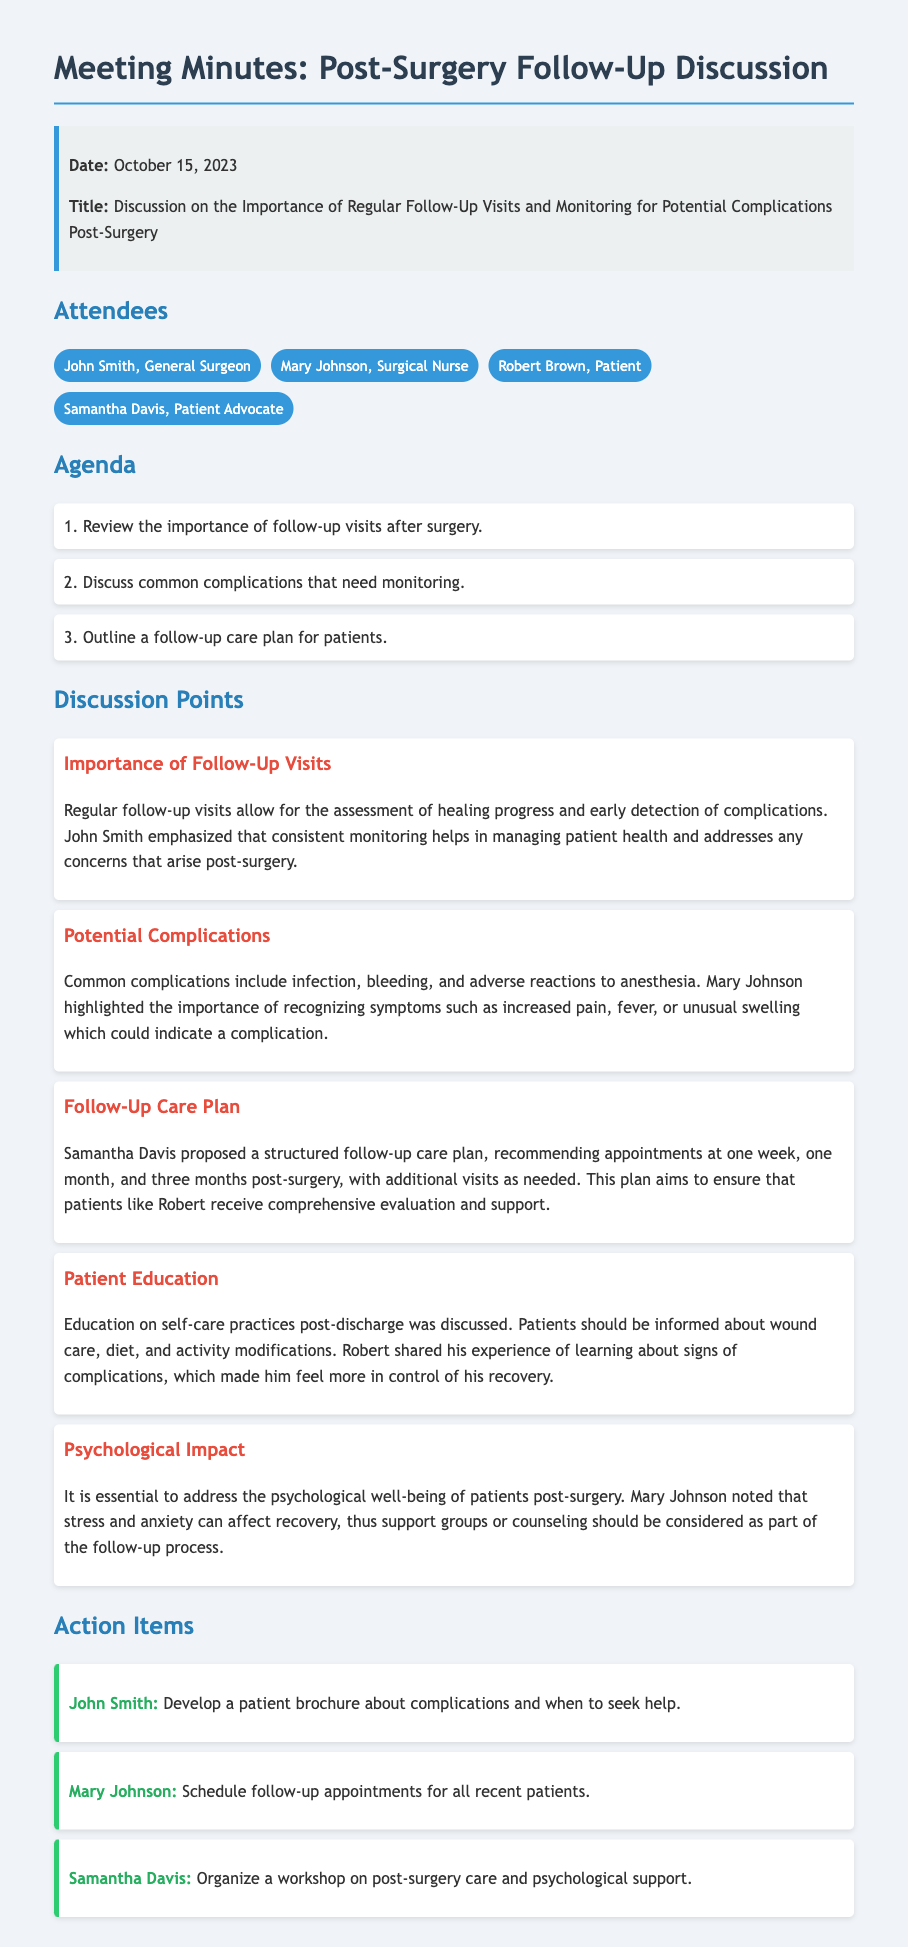What is the date of the meeting? The date of the meeting is explicitly mentioned in the meeting info section.
Answer: October 15, 2023 Who proposed the follow-up care plan? The follow-up care plan proposal is attributed to a specific attendee in the discussion points.
Answer: Samantha Davis What is one common complication discussed? The discussion point outlines a few complications mentioned during the meeting.
Answer: Infection How often are follow-up appointments recommended? The follow-up care plan details the timeline for follow-up visits.
Answer: One week, one month, and three months What aspect of recovery should be addressed according to Mary Johnson? The relevance of a certain emotional aspect is highlighted in relation to patient recovery.
Answer: Psychological well-being What action is John Smith responsible for after the meeting? The action items list specific responsibilities assigned to attendees.
Answer: Develop a patient brochure about complications and when to seek help What is the main focus of the meeting? The title of the meeting clearly indicates the topic being addressed.
Answer: Importance of Regular Follow-Up Visits and Monitoring Which attendee is identified as a Patient Advocate? The list of attendees includes their roles and contributions.
Answer: Samantha Davis 